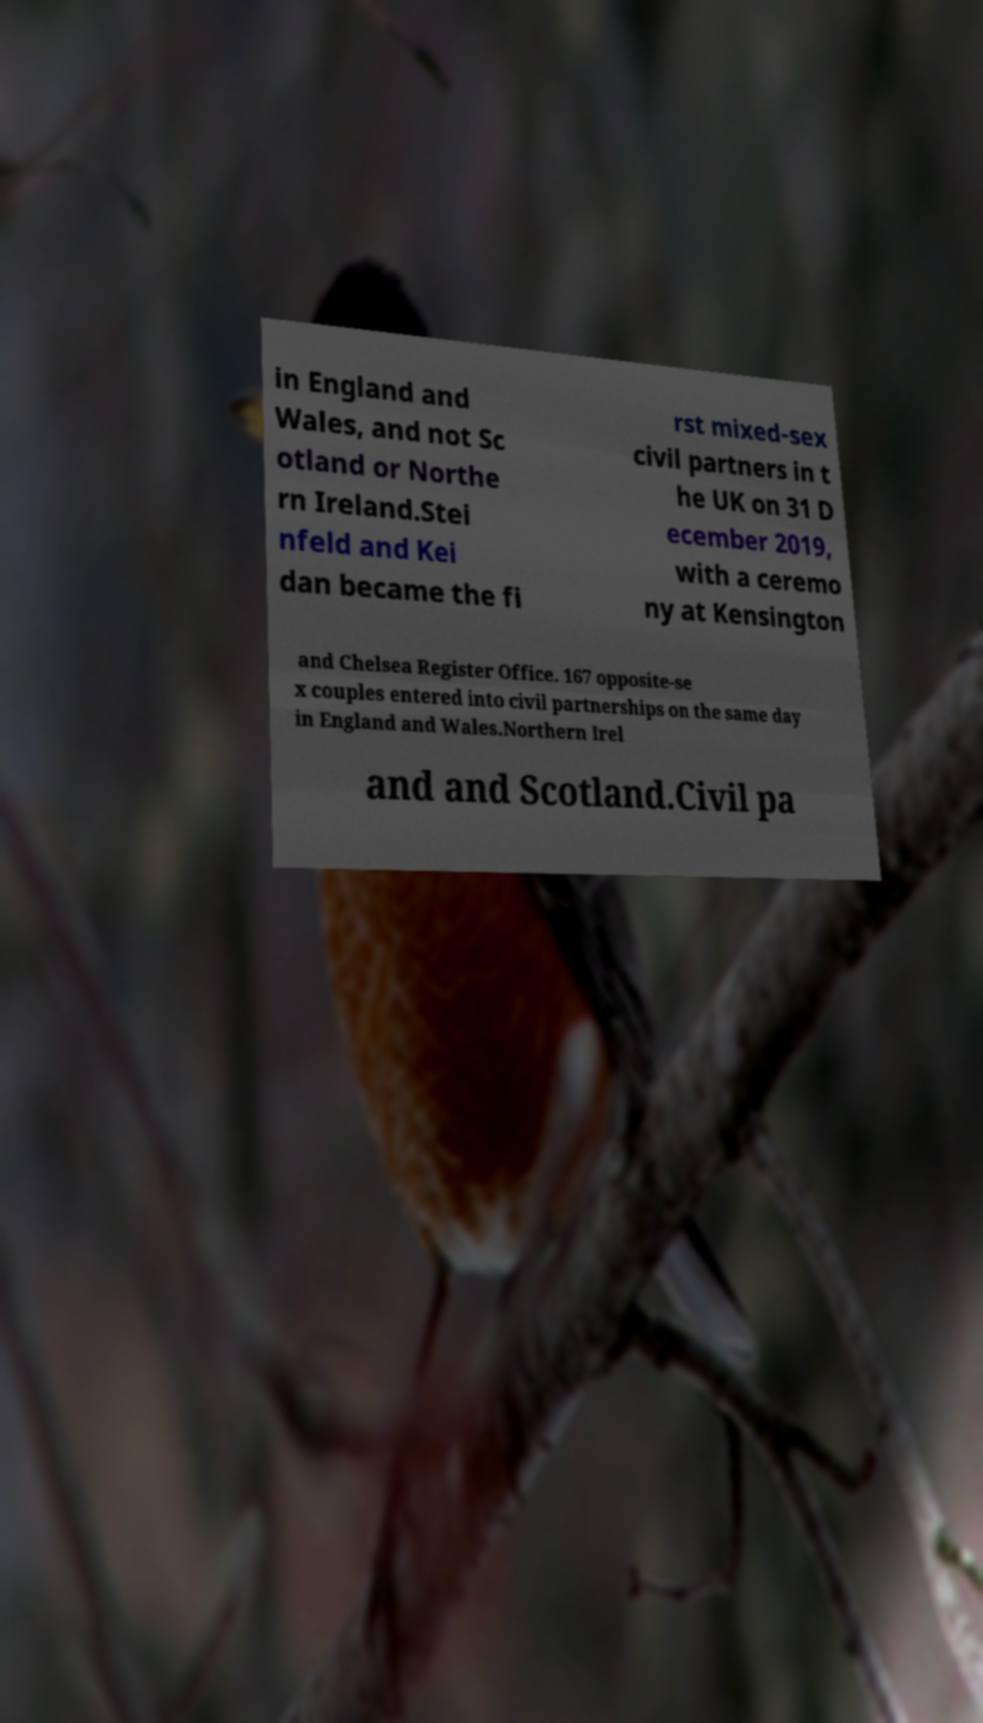What messages or text are displayed in this image? I need them in a readable, typed format. in England and Wales, and not Sc otland or Northe rn Ireland.Stei nfeld and Kei dan became the fi rst mixed-sex civil partners in t he UK on 31 D ecember 2019, with a ceremo ny at Kensington and Chelsea Register Office. 167 opposite-se x couples entered into civil partnerships on the same day in England and Wales.Northern Irel and and Scotland.Civil pa 